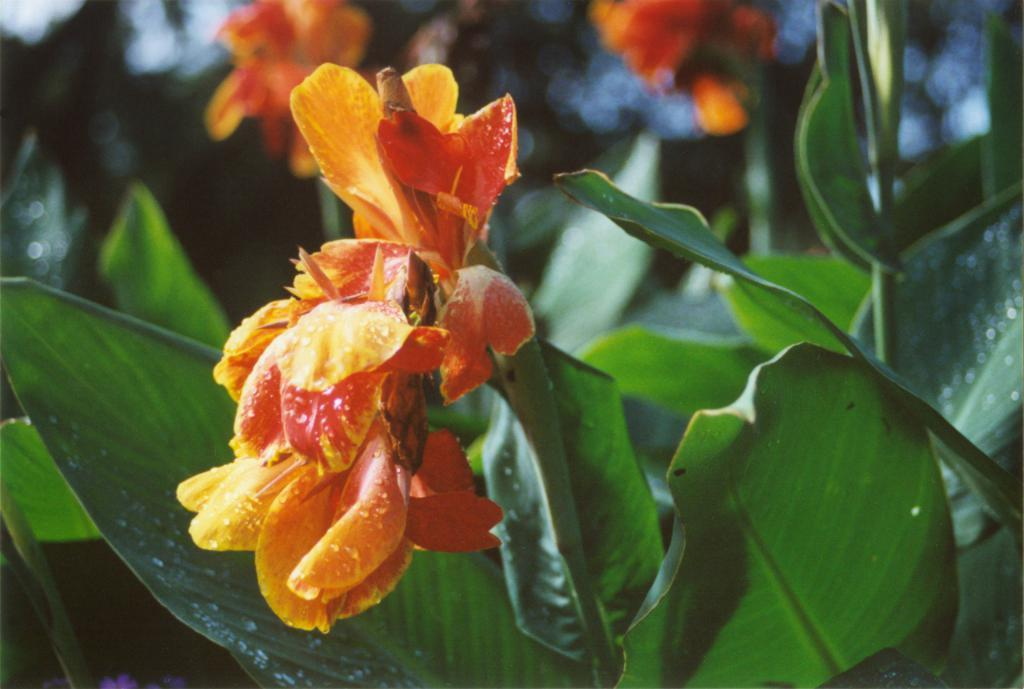What is the main subject of the image? The main subject of the image is plants with flowers. Can you describe the background of the image? The background of the image is blurred. What time of day is it at the playground in the image? There is no playground present in the image, so it is not possible to determine the time of day. 